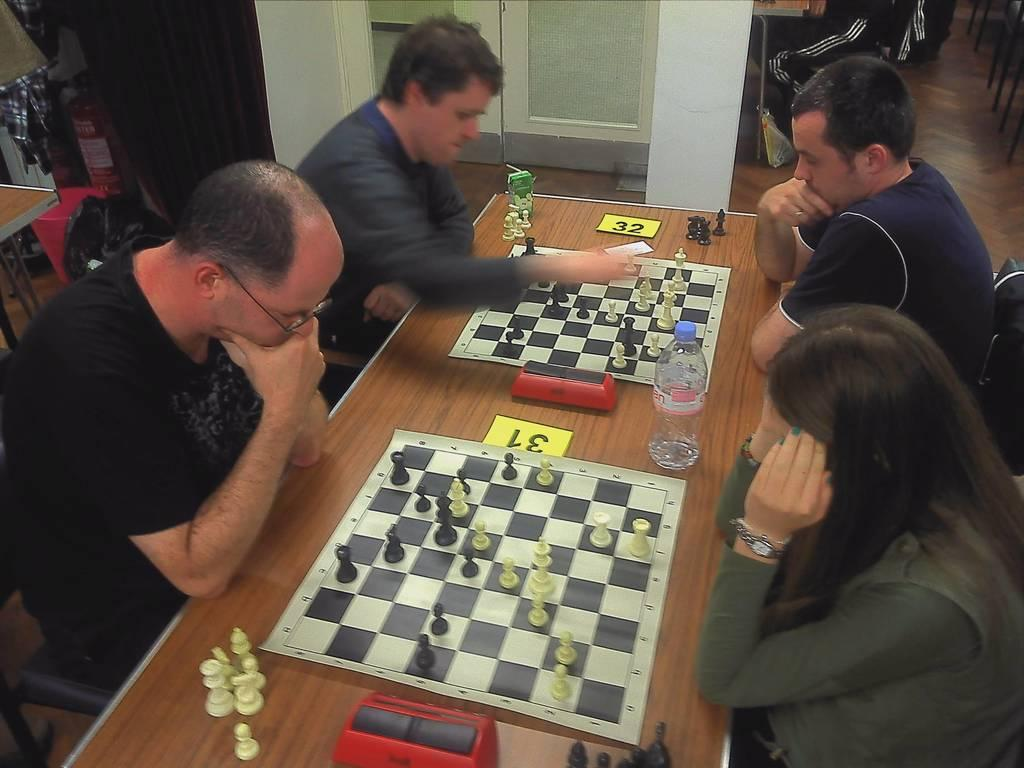How many people are in the image? There are four people in the image. What are the people doing in the image? The people are playing chess. What are the chess players using for support? The chess players are using a table for support. What can be seen on the table besides the chessboard? There is a water bottle on the table. Where does the scene take place? The scene takes place on a floor. What type of stew is being prepared on the table in the image? There is no stew being prepared in the image; the table is being used for playing chess. What type of scissors are the chess players using to cut the pieces? There are no scissors present in the image; the chess players are using chess pieces for their game. 